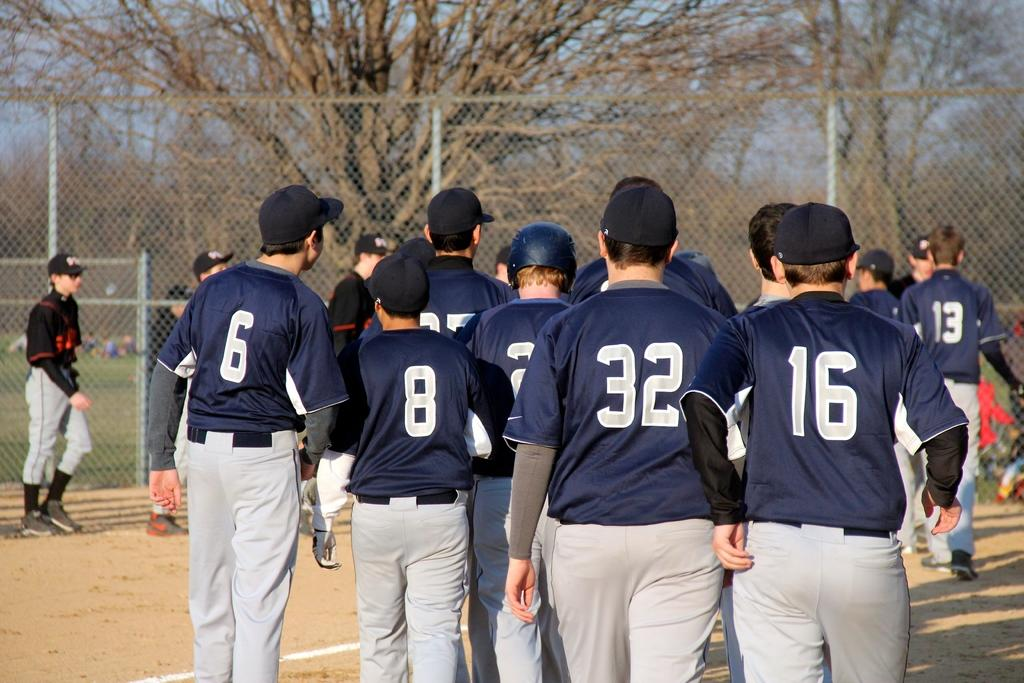<image>
Share a concise interpretation of the image provided. A group of baseball players, the shortest one has the number 8 on his shirt. 